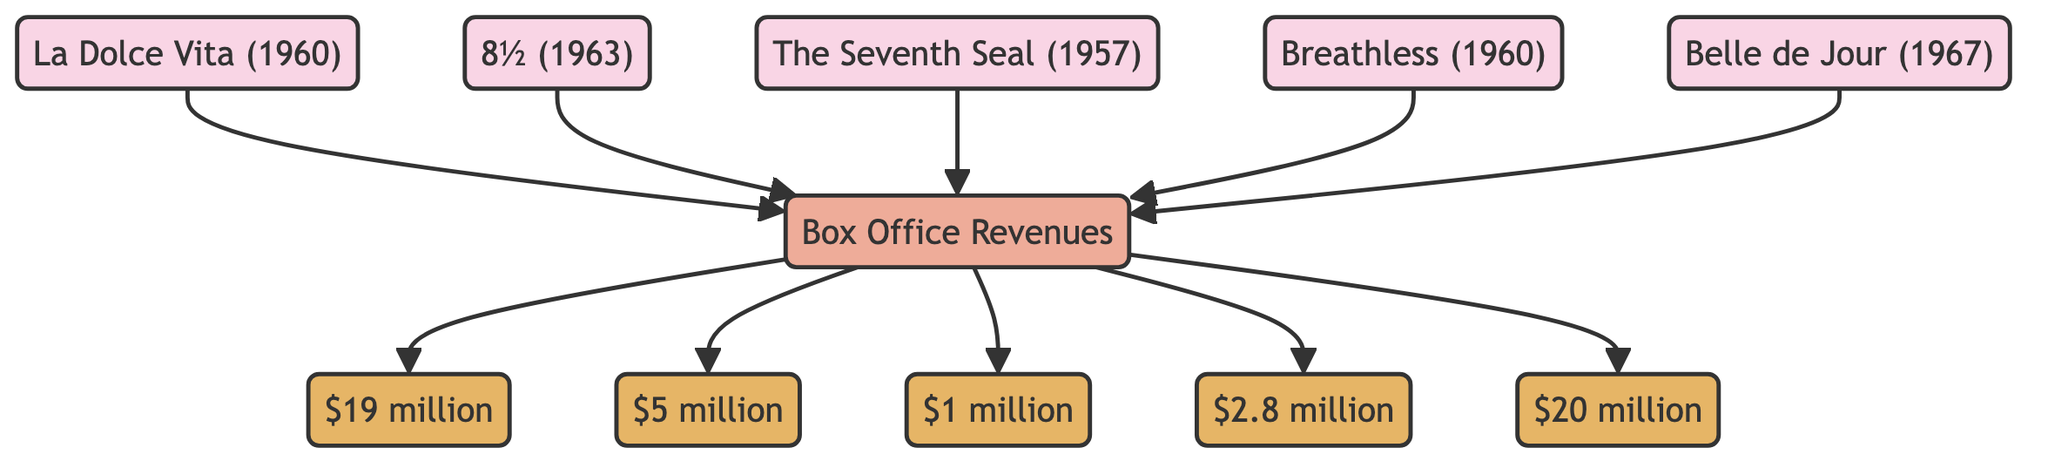What is the box office revenue for "La Dolce Vita"? The diagram indicates that "La Dolce Vita" has a box office revenue of "$19 million", which is explicitly labeled next to the film node.
Answer: $19 million Which film has the lowest box office revenue? By examining the revenue values associated with each film, "The Seventh Seal" shows the lowest box office revenue at "$1 million". This is the smallest amount when compared to the other listed films.
Answer: $1 million How many films are represented in the diagram? The diagram displays five distinct film nodes: "La Dolce Vita", "8½", "The Seventh Seal", "Breathless", and "Belle de Jour". Count each film node to determine the total.
Answer: 5 What is the total box office revenue for "Belle de Jour" and "La Dolce Vita"? First, identify the revenues for both films. "Belle de Jour" is labeled as "$20 million" and "La Dolce Vita" is "$19 million". Adding these two amounts gives a total of "$39 million".
Answer: $39 million Which film has a box office revenue of "$2.8 million"? The diagram directly associates the revenue of "$2.8 million" with the film "Breathless". This is evident from the link connecting the film to its revenue node.
Answer: Breathless How do the revenues of "8½" and "Breathless" compare? The diagram specifies that "8½" has a revenue of "$5 million" while "Breathless" has a revenue of "$2.8 million". To compare, "$5 million" is greater than "$2.8 million".
Answer: 8½ has higher revenue What is the difference in box office revenue between "Belle de Jour" and "8½"? The revenue for "Belle de Jour" is "$20 million" and for "8½" is "$5 million". Subtracting the latter from the former gives a difference of "$15 million". This indicates how much more "Belle de Jour" made compared to "8½".
Answer: $15 million Which film has a greater box office revenue: "The Seventh Seal" or "Breathless"? The revenue for "The Seventh Seal" is "$1 million" while "Breathless" has "$2.8 million". When comparing these two figures, "$2.8 million" for "Breathless" is greater than "$1 million" for "The Seventh Seal".
Answer: Breathless What is the total box office revenue of all films combined? To find the total combined revenue, add up the revenues of all the films: "$19 million" + "$5 million" + "$1 million" + "$2.8 million" + "$20 million", which totals "$47.8 million".
Answer: $47.8 million 